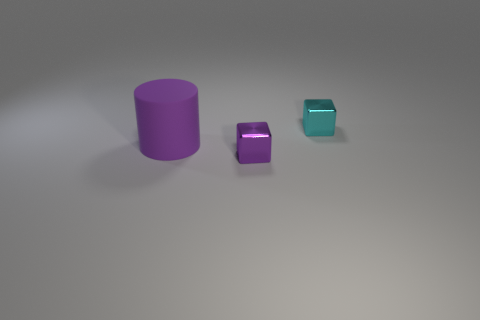Add 2 cyan matte cubes. How many objects exist? 5 Subtract all blocks. How many objects are left? 1 Add 2 gray shiny objects. How many gray shiny objects exist? 2 Subtract 0 green blocks. How many objects are left? 3 Subtract all small cyan spheres. Subtract all large purple cylinders. How many objects are left? 2 Add 3 small purple cubes. How many small purple cubes are left? 4 